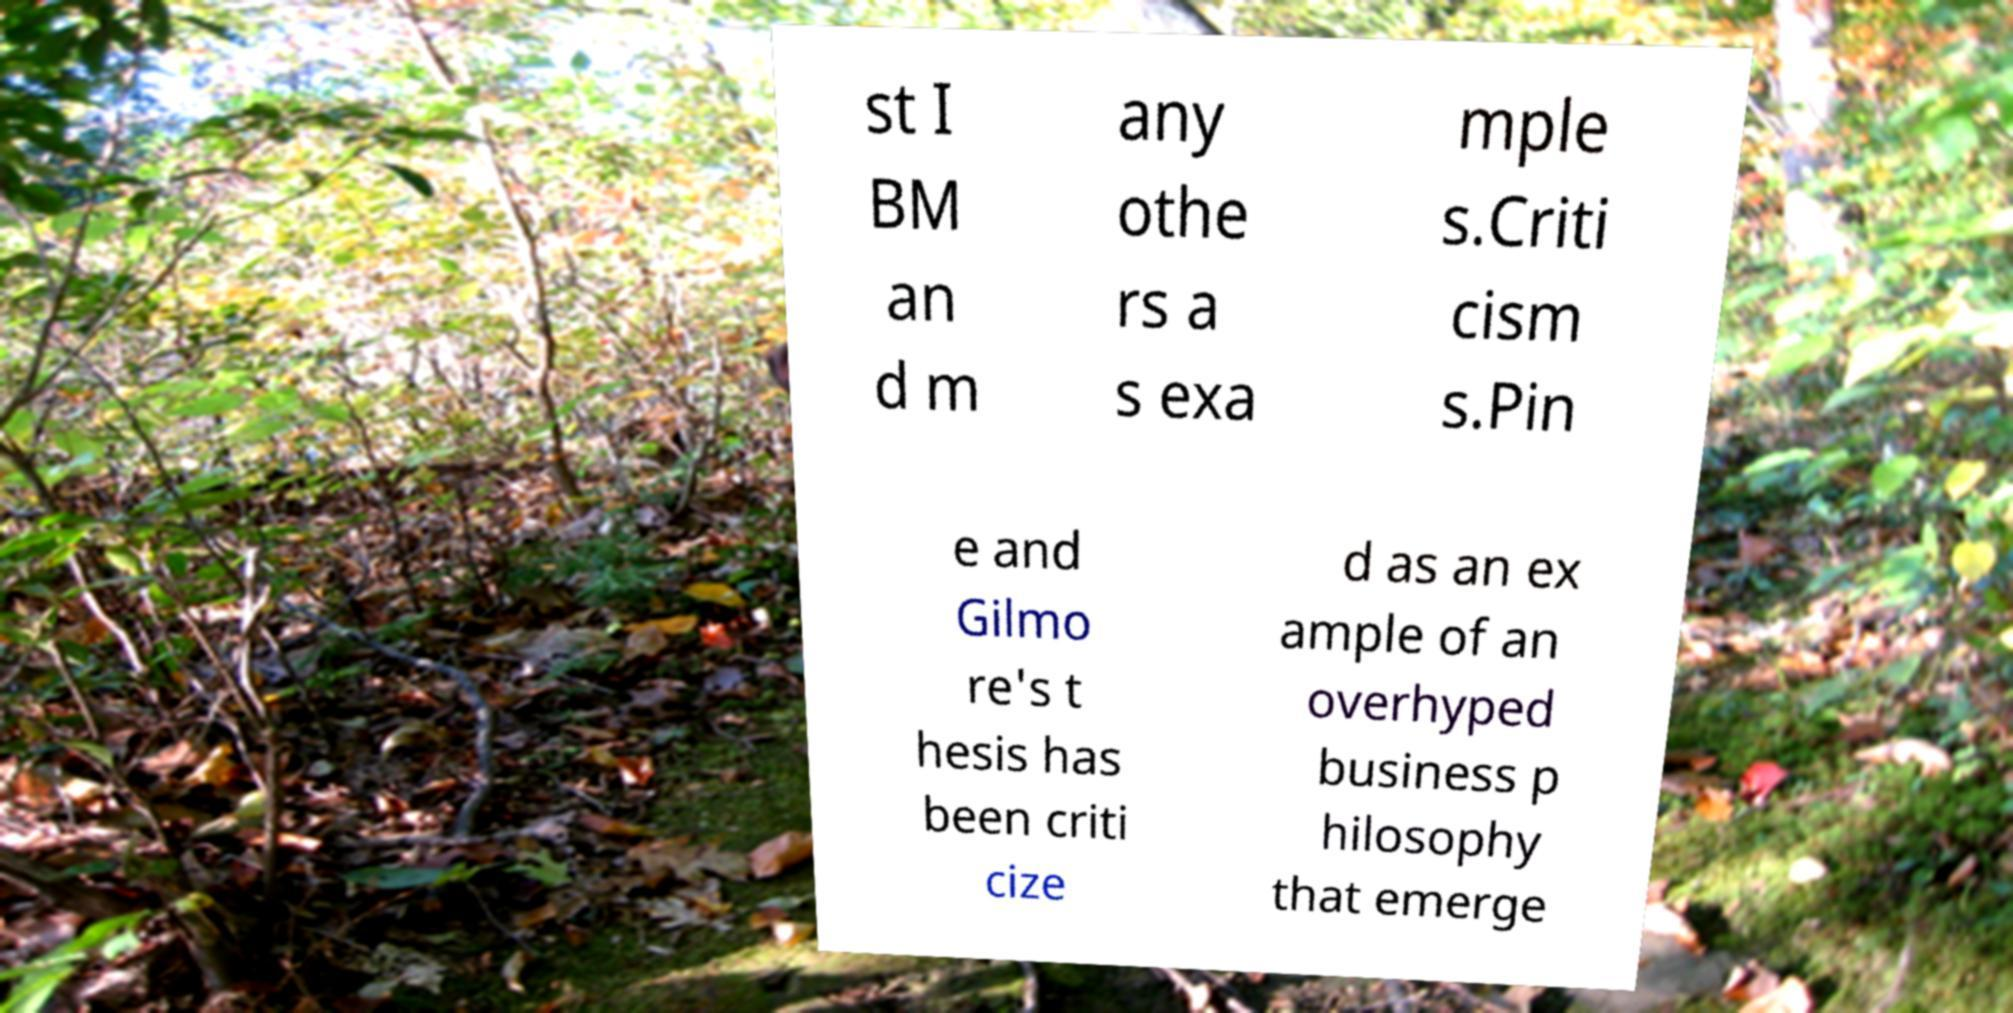Can you read and provide the text displayed in the image?This photo seems to have some interesting text. Can you extract and type it out for me? st I BM an d m any othe rs a s exa mple s.Criti cism s.Pin e and Gilmo re's t hesis has been criti cize d as an ex ample of an overhyped business p hilosophy that emerge 